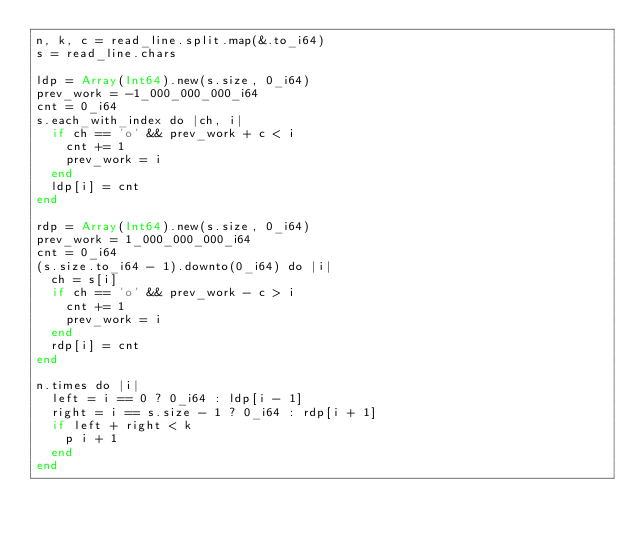<code> <loc_0><loc_0><loc_500><loc_500><_Crystal_>n, k, c = read_line.split.map(&.to_i64)
s = read_line.chars

ldp = Array(Int64).new(s.size, 0_i64)
prev_work = -1_000_000_000_i64
cnt = 0_i64
s.each_with_index do |ch, i|
  if ch == 'o' && prev_work + c < i
    cnt += 1
    prev_work = i
  end
  ldp[i] = cnt
end

rdp = Array(Int64).new(s.size, 0_i64)
prev_work = 1_000_000_000_i64
cnt = 0_i64
(s.size.to_i64 - 1).downto(0_i64) do |i|
  ch = s[i]
  if ch == 'o' && prev_work - c > i
    cnt += 1
    prev_work = i
  end
  rdp[i] = cnt
end

n.times do |i|
  left = i == 0 ? 0_i64 : ldp[i - 1]
  right = i == s.size - 1 ? 0_i64 : rdp[i + 1]
  if left + right < k
    p i + 1
  end
end
</code> 